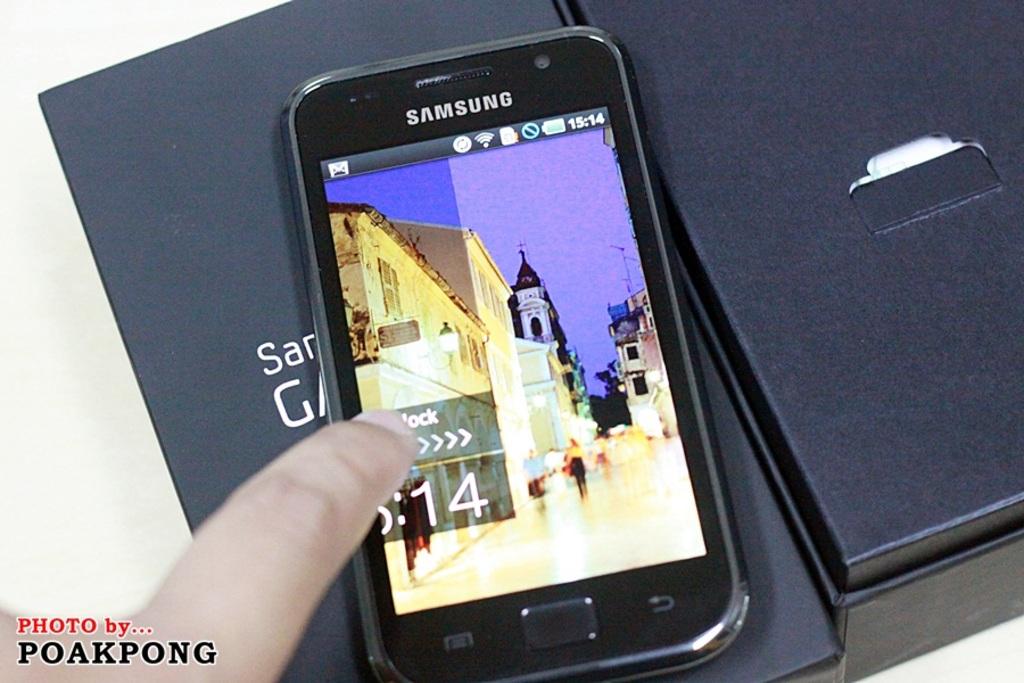Who makes this phone?
Offer a very short reply. Samsung. Who took the photo?
Make the answer very short. Poakpong. 